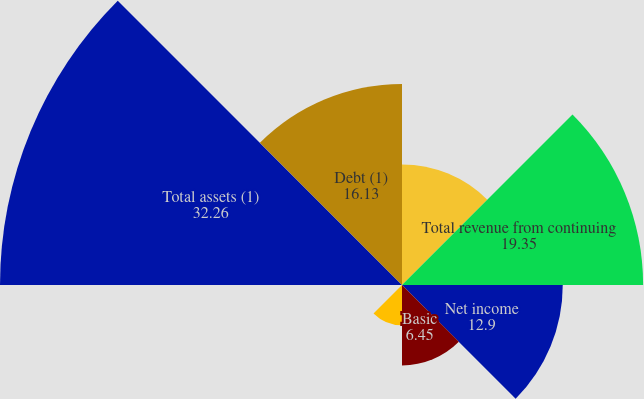Convert chart to OTSL. <chart><loc_0><loc_0><loc_500><loc_500><pie_chart><fcel>(thousands except per share<fcel>Total revenue from continuing<fcel>Net income<fcel>Basic<fcel>Diluted<fcel>Cash dividends declared per<fcel>Total assets (1)<fcel>Debt (1)<nl><fcel>9.68%<fcel>19.35%<fcel>12.9%<fcel>6.45%<fcel>3.23%<fcel>0.0%<fcel>32.26%<fcel>16.13%<nl></chart> 